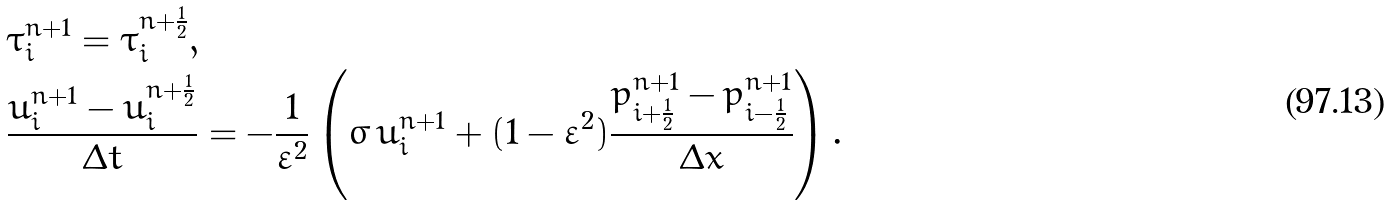<formula> <loc_0><loc_0><loc_500><loc_500>& \tau _ { i } ^ { n + 1 } = \tau _ { i } ^ { n + \frac { 1 } { 2 } } , \\ & \frac { u _ { i } ^ { n + 1 } - u _ { i } ^ { n + \frac { 1 } { 2 } } } { \Delta t } = - \frac { 1 } { \varepsilon ^ { 2 } } \left ( \sigma \, u _ { i } ^ { n + 1 } + ( 1 - \varepsilon ^ { 2 } ) \frac { p _ { i + \frac { 1 } { 2 } } ^ { n + 1 } - p _ { i - \frac { 1 } { 2 } } ^ { n + 1 } } { \Delta x } \right ) .</formula> 